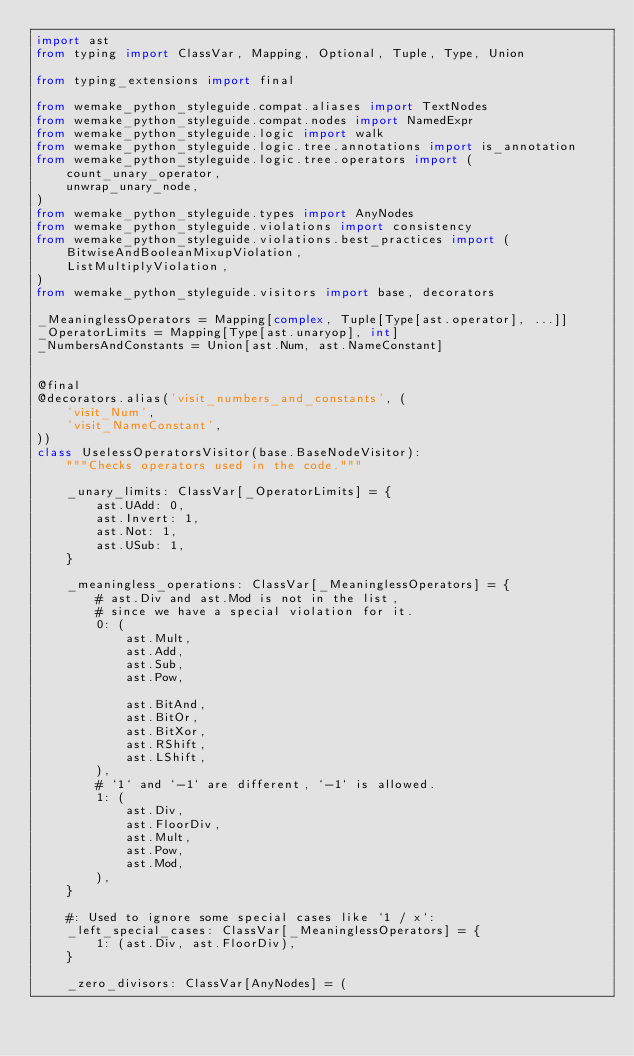<code> <loc_0><loc_0><loc_500><loc_500><_Python_>import ast
from typing import ClassVar, Mapping, Optional, Tuple, Type, Union

from typing_extensions import final

from wemake_python_styleguide.compat.aliases import TextNodes
from wemake_python_styleguide.compat.nodes import NamedExpr
from wemake_python_styleguide.logic import walk
from wemake_python_styleguide.logic.tree.annotations import is_annotation
from wemake_python_styleguide.logic.tree.operators import (
    count_unary_operator,
    unwrap_unary_node,
)
from wemake_python_styleguide.types import AnyNodes
from wemake_python_styleguide.violations import consistency
from wemake_python_styleguide.violations.best_practices import (
    BitwiseAndBooleanMixupViolation,
    ListMultiplyViolation,
)
from wemake_python_styleguide.visitors import base, decorators

_MeaninglessOperators = Mapping[complex, Tuple[Type[ast.operator], ...]]
_OperatorLimits = Mapping[Type[ast.unaryop], int]
_NumbersAndConstants = Union[ast.Num, ast.NameConstant]


@final
@decorators.alias('visit_numbers_and_constants', (
    'visit_Num',
    'visit_NameConstant',
))
class UselessOperatorsVisitor(base.BaseNodeVisitor):
    """Checks operators used in the code."""

    _unary_limits: ClassVar[_OperatorLimits] = {
        ast.UAdd: 0,
        ast.Invert: 1,
        ast.Not: 1,
        ast.USub: 1,
    }

    _meaningless_operations: ClassVar[_MeaninglessOperators] = {
        # ast.Div and ast.Mod is not in the list,
        # since we have a special violation for it.
        0: (
            ast.Mult,
            ast.Add,
            ast.Sub,
            ast.Pow,

            ast.BitAnd,
            ast.BitOr,
            ast.BitXor,
            ast.RShift,
            ast.LShift,
        ),
        # `1` and `-1` are different, `-1` is allowed.
        1: (
            ast.Div,
            ast.FloorDiv,
            ast.Mult,
            ast.Pow,
            ast.Mod,
        ),
    }

    #: Used to ignore some special cases like `1 / x`:
    _left_special_cases: ClassVar[_MeaninglessOperators] = {
        1: (ast.Div, ast.FloorDiv),
    }

    _zero_divisors: ClassVar[AnyNodes] = (</code> 